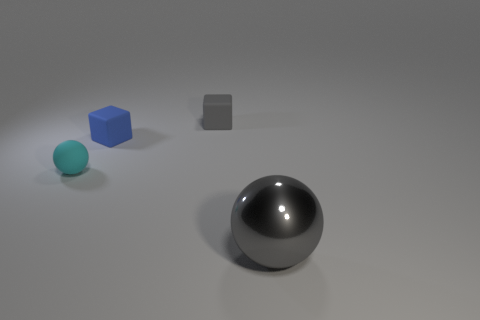There is a cube that is the same color as the large sphere; what is its size?
Your response must be concise. Small. Does the metallic object have the same color as the tiny matte block that is behind the blue rubber thing?
Provide a succinct answer. Yes. There is a thing that is right of the gray thing that is behind the ball that is to the left of the metallic object; what is its shape?
Your response must be concise. Sphere. Are there any large objects that are on the left side of the gray thing behind the metal object?
Give a very brief answer. No. There is a small cyan object; is it the same shape as the tiny rubber object on the right side of the tiny blue rubber thing?
Ensure brevity in your answer.  No. What number of gray objects are either large spheres or small rubber cubes?
Give a very brief answer. 2. How many things are behind the big metal ball and on the right side of the blue matte block?
Provide a succinct answer. 1. There is a sphere on the right side of the gray thing that is behind the ball behind the shiny ball; what is it made of?
Ensure brevity in your answer.  Metal. How many tiny green balls have the same material as the blue object?
Offer a terse response. 0. There is another matte thing that is the same color as the large object; what shape is it?
Your response must be concise. Cube. 